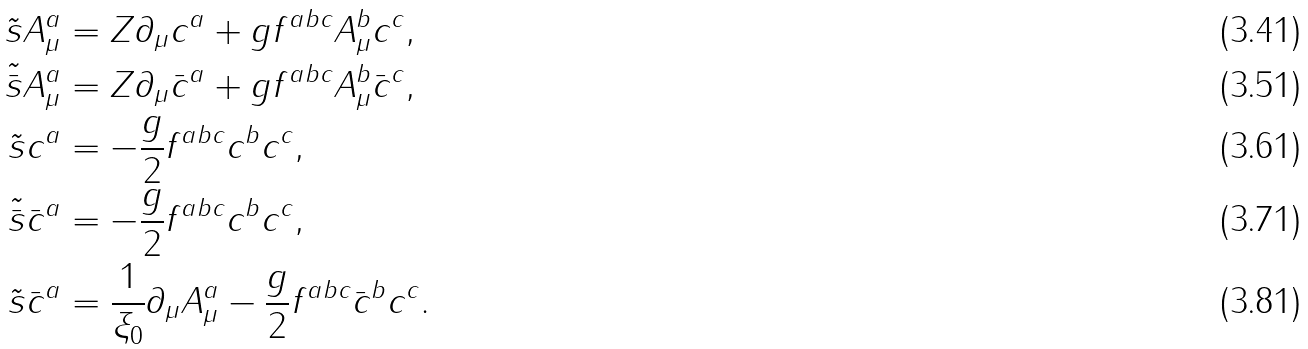<formula> <loc_0><loc_0><loc_500><loc_500>\tilde { s } A _ { \mu } ^ { a } & = Z \partial _ { \mu } c ^ { a } + g f ^ { a b c } A _ { \mu } ^ { b } c ^ { c } , \\ \tilde { \bar { s } } A _ { \mu } ^ { a } & = Z \partial _ { \mu } \bar { c } ^ { a } + g f ^ { a b c } A _ { \mu } ^ { b } \bar { c } ^ { c } , \\ \tilde { s } c ^ { a } & = - \frac { g } { 2 } f ^ { a b c } c ^ { b } c ^ { c } , \\ \tilde { \bar { s } } \bar { c } ^ { a } & = - \frac { g } { 2 } f ^ { a b c } c ^ { b } c ^ { c } , \\ \tilde { s } \bar { c } ^ { a } & = \frac { 1 } { \xi _ { 0 } } \partial _ { \mu } A _ { \mu } ^ { a } - \frac { g } { 2 } f ^ { a b c } \bar { c } ^ { b } c ^ { c } .</formula> 